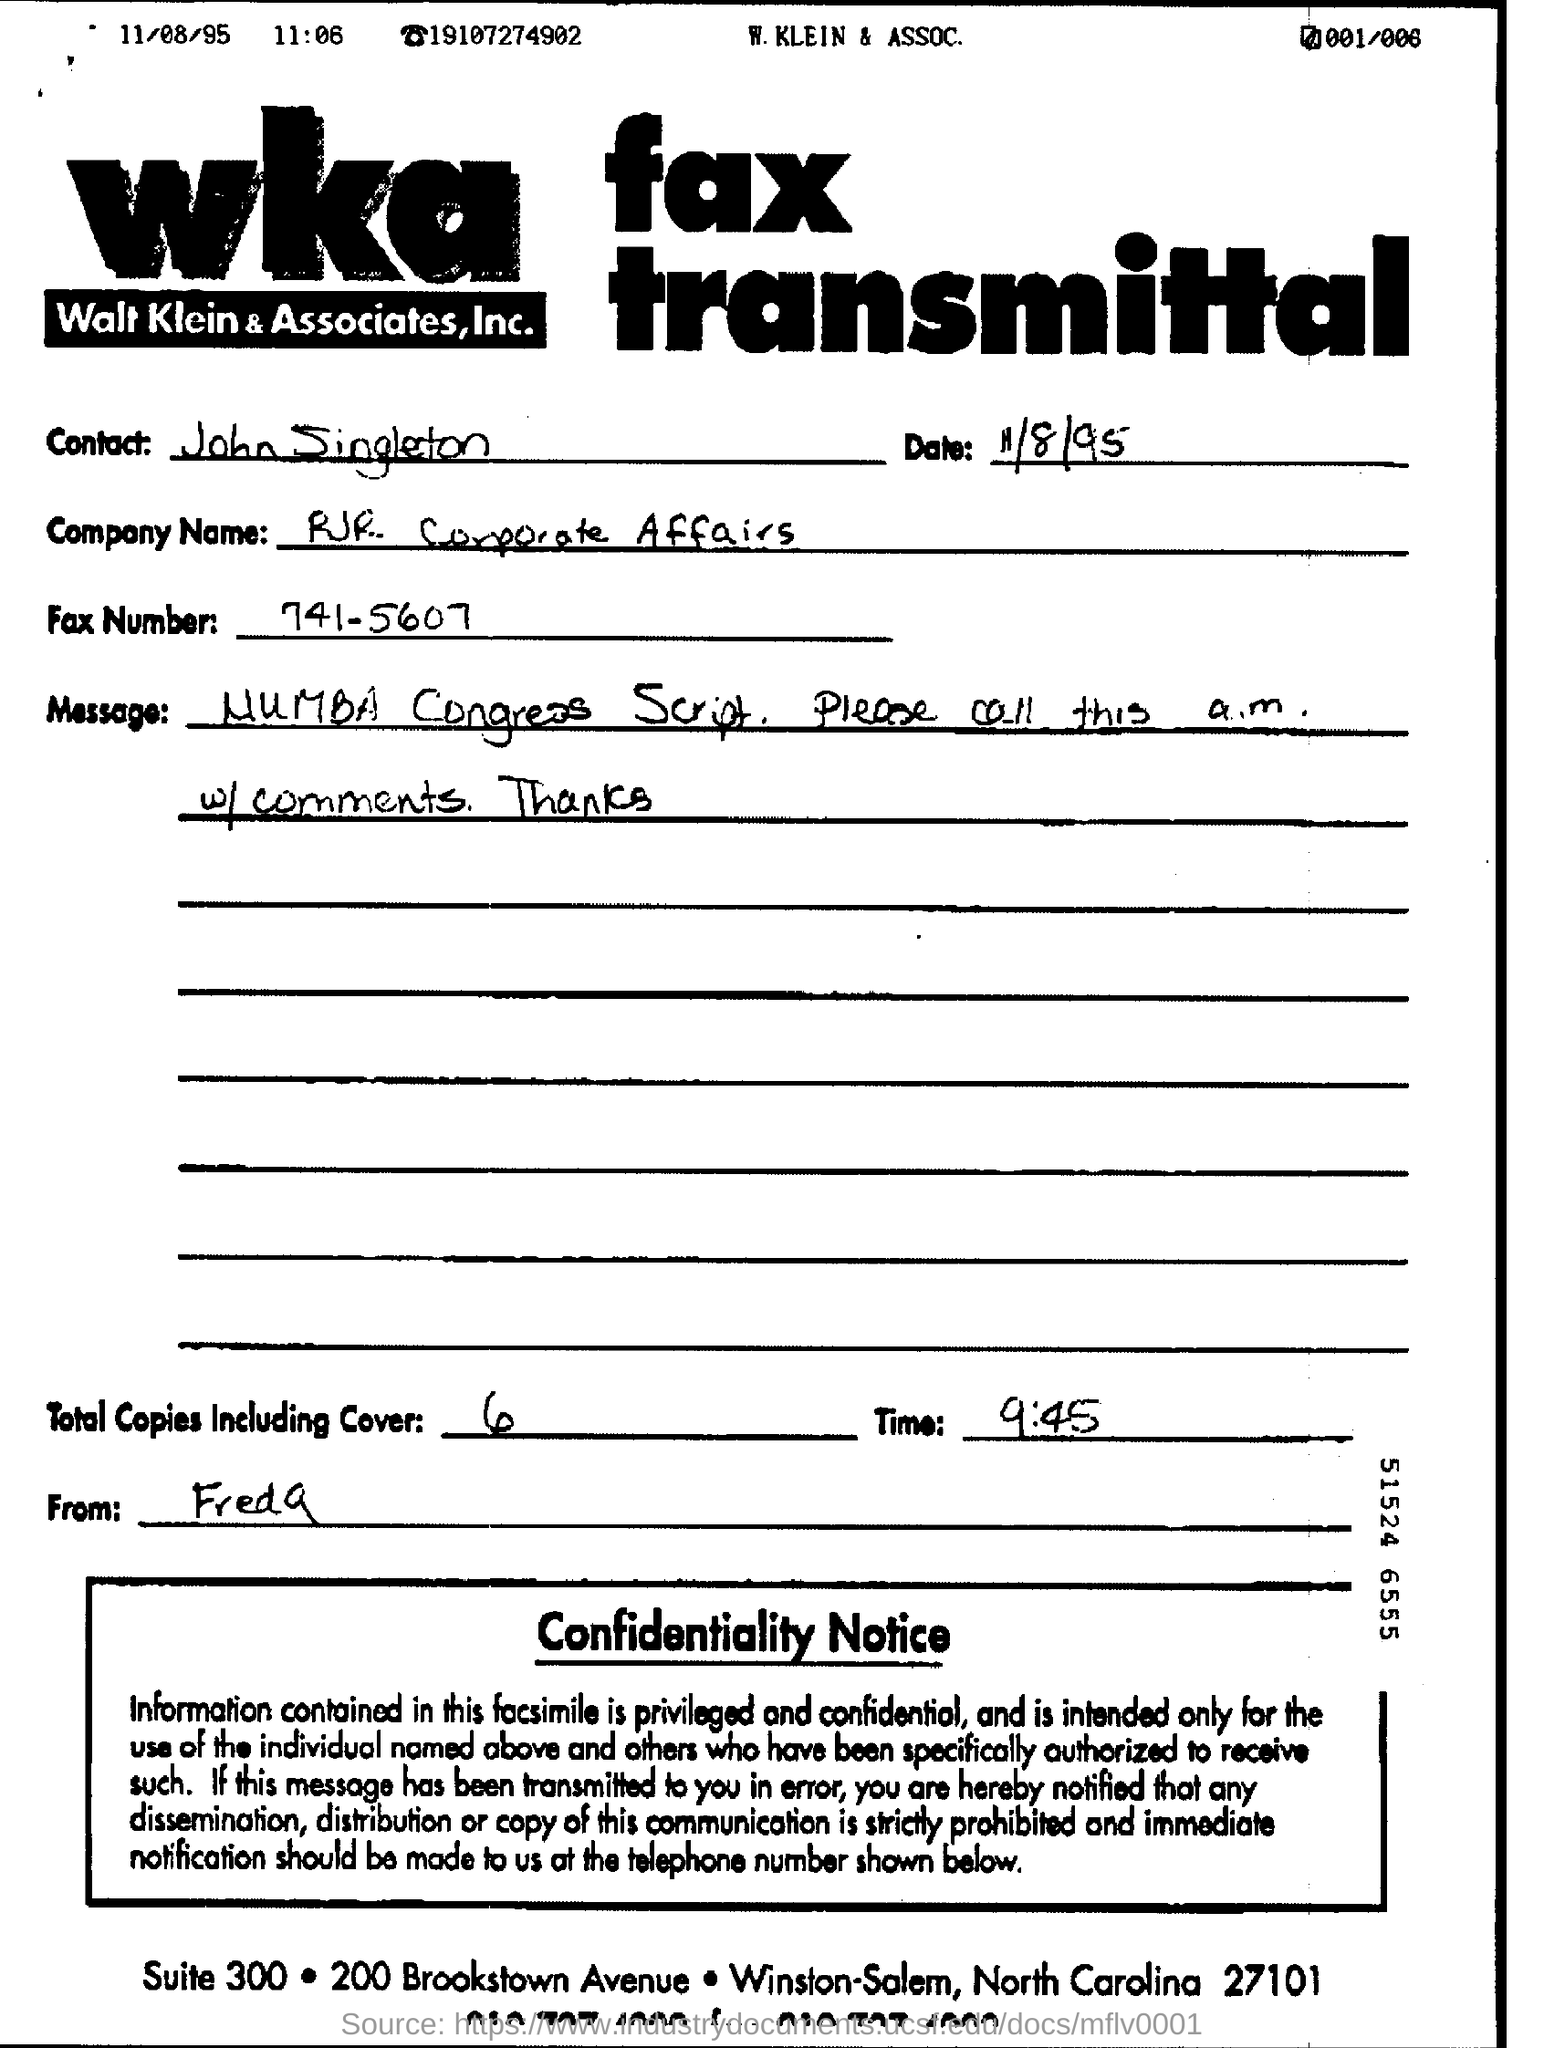Who is the Contact?
Offer a very short reply. John Singleton. What is the Company Name?
Ensure brevity in your answer.  RJR Corporate Affairs. What is the Fax Number?
Ensure brevity in your answer.  741-5607. What is the date on the Fax?
Provide a short and direct response. 11/8/95. 